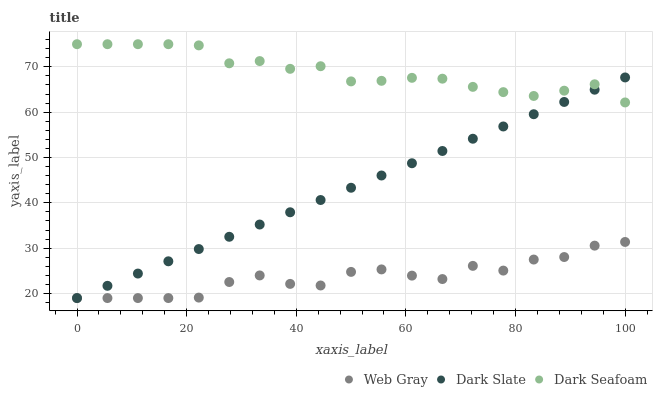Does Web Gray have the minimum area under the curve?
Answer yes or no. Yes. Does Dark Seafoam have the maximum area under the curve?
Answer yes or no. Yes. Does Dark Seafoam have the minimum area under the curve?
Answer yes or no. No. Does Web Gray have the maximum area under the curve?
Answer yes or no. No. Is Dark Slate the smoothest?
Answer yes or no. Yes. Is Web Gray the roughest?
Answer yes or no. Yes. Is Dark Seafoam the smoothest?
Answer yes or no. No. Is Dark Seafoam the roughest?
Answer yes or no. No. Does Dark Slate have the lowest value?
Answer yes or no. Yes. Does Dark Seafoam have the lowest value?
Answer yes or no. No. Does Dark Seafoam have the highest value?
Answer yes or no. Yes. Does Web Gray have the highest value?
Answer yes or no. No. Is Web Gray less than Dark Seafoam?
Answer yes or no. Yes. Is Dark Seafoam greater than Web Gray?
Answer yes or no. Yes. Does Web Gray intersect Dark Slate?
Answer yes or no. Yes. Is Web Gray less than Dark Slate?
Answer yes or no. No. Is Web Gray greater than Dark Slate?
Answer yes or no. No. Does Web Gray intersect Dark Seafoam?
Answer yes or no. No. 